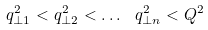Convert formula to latex. <formula><loc_0><loc_0><loc_500><loc_500>q _ { \perp 1 } ^ { 2 } < q _ { \perp 2 } ^ { 2 } < \dots \ q _ { \perp n } ^ { 2 } < Q ^ { 2 }</formula> 